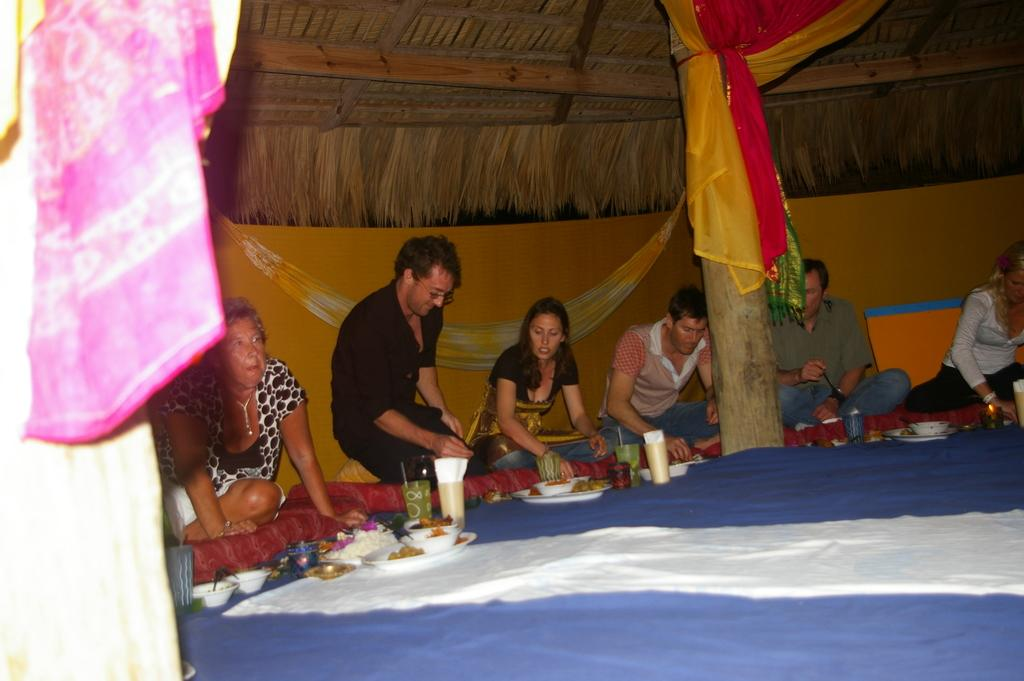What type of structure can be seen in the image? There is a wall and a pillar in the image. What type of covering is present in the image? There are cloths and a roof in the image. What type of objects are present in the image? There are plates, glasses, bowls, and other objects in the image. What is the purpose of the objects in the image? The plates, glasses, and bowls are likely used for serving food, which is present in the image. What are the people in the image doing? There are people in the image, and one person is holding food. How many pies are on the table in the image? There is no mention of pies in the image; only plates, glasses, bowls, and food are present. What type of spot can be seen on the wall in the image? There is no mention of a spot on the wall in the image. What is the person holding food using to tighten the screws in the image? There is no mention of screws or a wrench in the image; the person is simply holding food. 